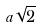<formula> <loc_0><loc_0><loc_500><loc_500>a \sqrt { 2 }</formula> 